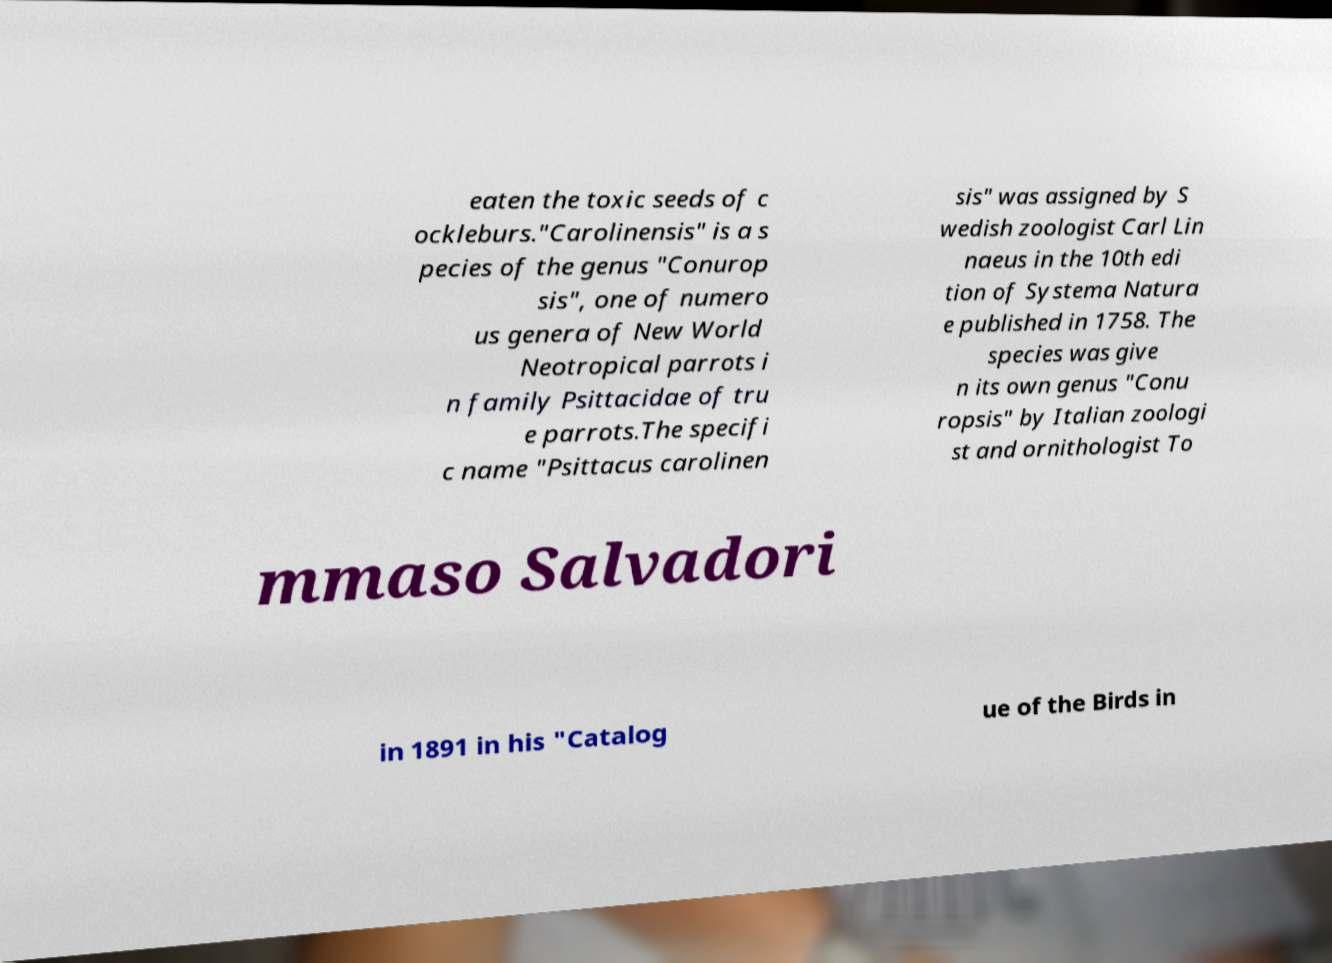There's text embedded in this image that I need extracted. Can you transcribe it verbatim? eaten the toxic seeds of c ockleburs."Carolinensis" is a s pecies of the genus "Conurop sis", one of numero us genera of New World Neotropical parrots i n family Psittacidae of tru e parrots.The specifi c name "Psittacus carolinen sis" was assigned by S wedish zoologist Carl Lin naeus in the 10th edi tion of Systema Natura e published in 1758. The species was give n its own genus "Conu ropsis" by Italian zoologi st and ornithologist To mmaso Salvadori in 1891 in his "Catalog ue of the Birds in 